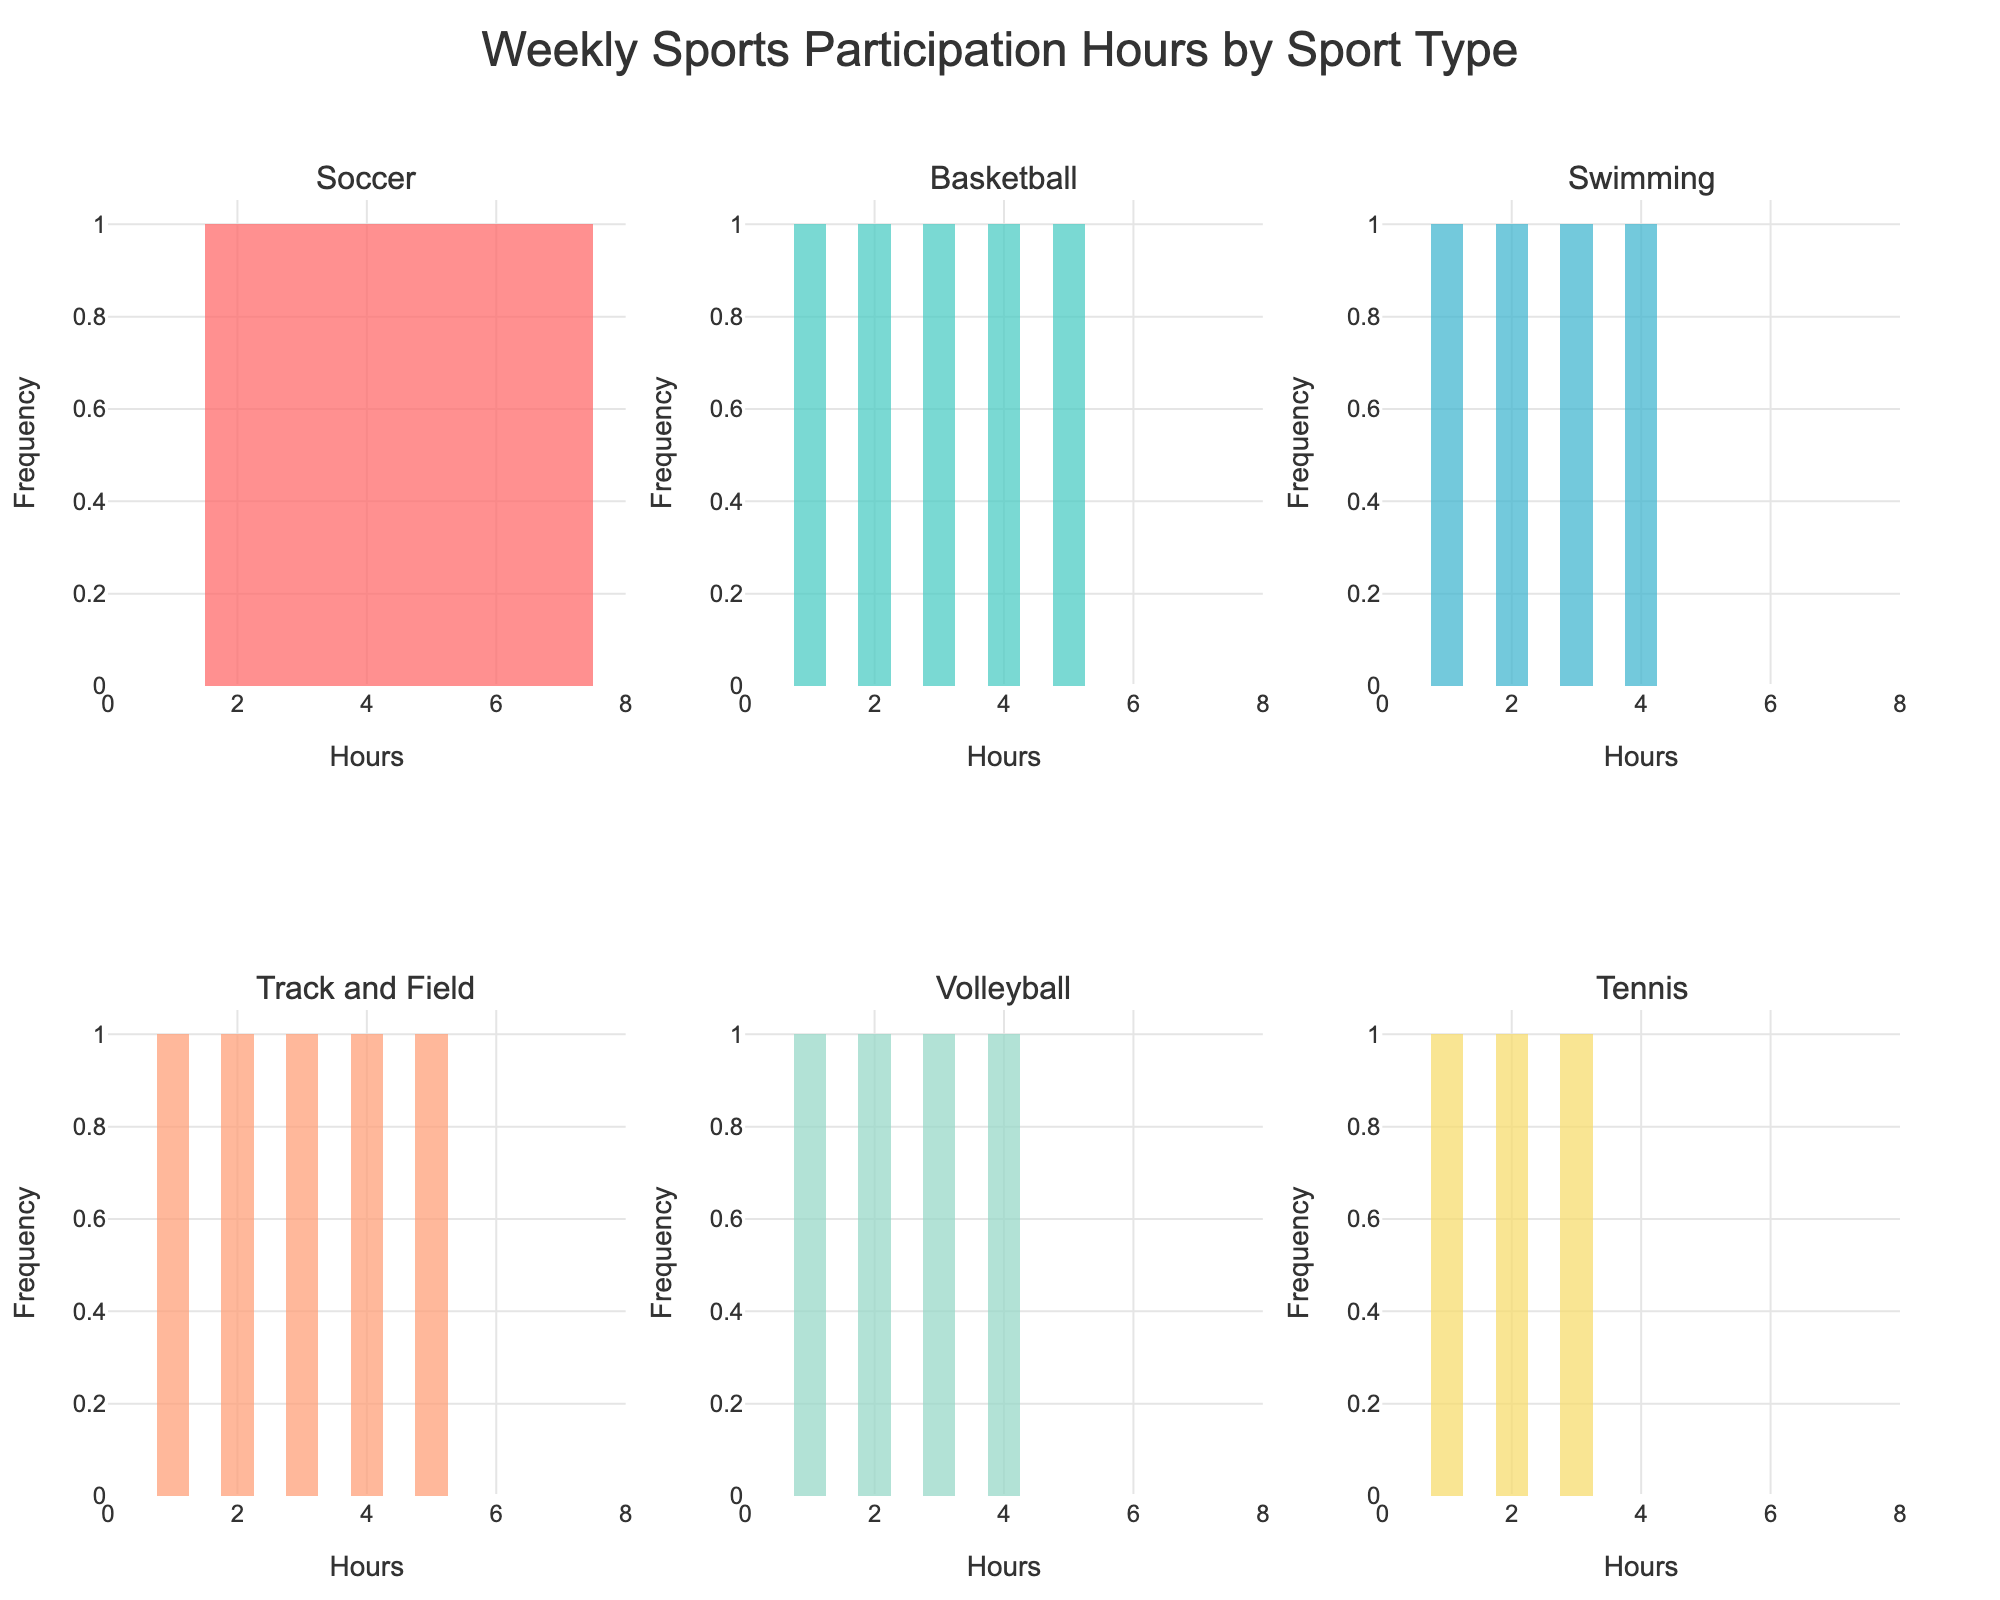what is the title of the plot? The title of the plot is displayed at the top of the figure. It reads "Weekly Sports Participation Hours by Sport Type."
Answer: Weekly Sports Participation Hours by Sport Type How many sports are displayed in the figure? Each subplot represents a different sport, and there are 6 subplots in total, corresponding to 6 different sports.
Answer: 6 Which sport has the most varied weekly participation hours? By examining the x-axes of the subplots, Soccer shows a wider range of weekly participation hours compared to the other sports, spanning from 2 to 7 hours.
Answer: Soccer What is the maximum number of weekly participation hours recorded for Tennis? By looking at the Tennis subplot, the highest value on the x-axis (Hours) is 3.
Answer: 3 Which sport has the highest frequency of 1-hour participation? The highest bar at the 1-hour mark is in the Volleyball subplot.
Answer: Volleyball Which sports have their frequencies peaking at 4 hours? By inspecting the subplots, Soccer and Swimming have bars peaking at the 4-hour mark.
Answer: Soccer, Swimming What is the difference in frequency between the 2-hour and 5-hour bins for Soccer? By examining the bars for Soccer, the frequency for 2 hours is 1 and for 5 hours is also 1; thus, the difference is 0.
Answer: 0 Which subplot shows the highest overall frequency for a single bin? Inspecting all subplots, Swimming at the 3-hour mark has the highest overall frequency.
Answer: Swimming How many subplots have the highest bin reaching at least 2 hours? By counting the bins in each subplot reaching at least 2 hours, all 6 subplots have bins that meet this criterion.
Answer: 6 Which sports have a maximum participation of 5 hours? Analyzing the x-axes, Soccer, Basketball, Volleyball, and Track and Field display a maximum participation of 5 hours.
Answer: Soccer, Basketball, Track and Field, Volleyball 